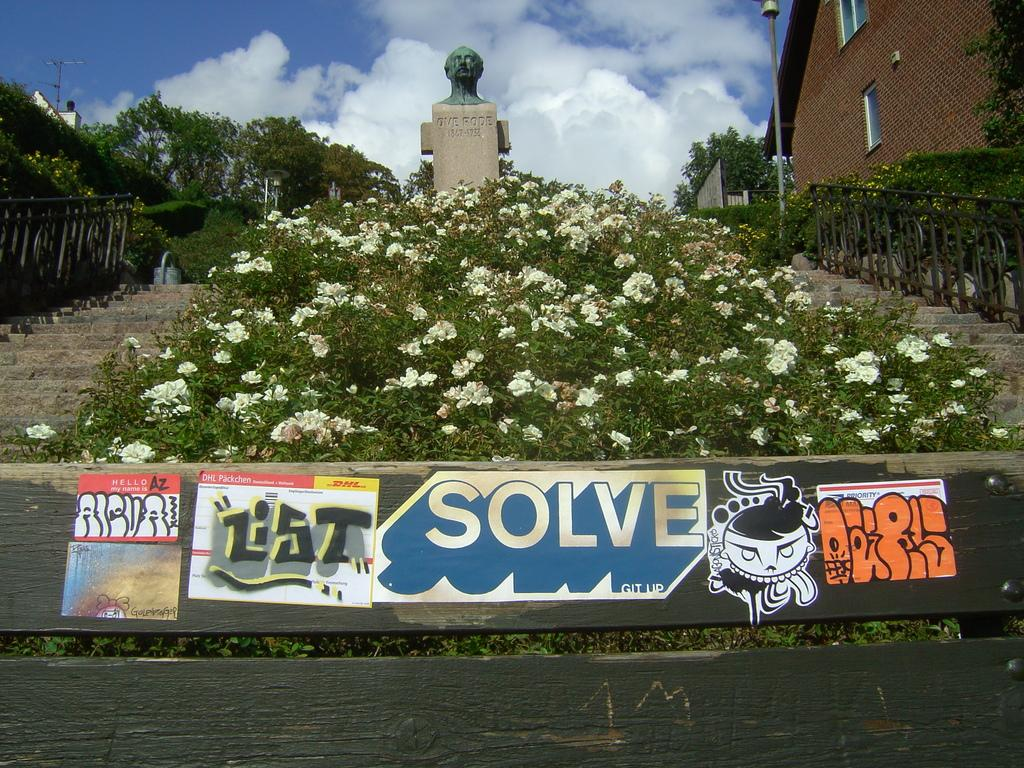What is the main object in the image? There is a board in the image. What type of plants can be seen in the image? There are plants and trees in the image. Are there any flowers visible in the image? Yes, there are flowers in the image. What type of structure can be seen in the image? There is a fence and a building in the image. What other objects can be seen in the image? There are poles, a sculpture, and windows in the image. What can be seen in the background of the image? The sky is visible in the background of the image, with clouds present. Where is the map located in the image? There is no map present in the image. What type of spoon is being used to create the sculpture in the image? There is no spoon present in the image, and the sculpture does not appear to be made with one. 